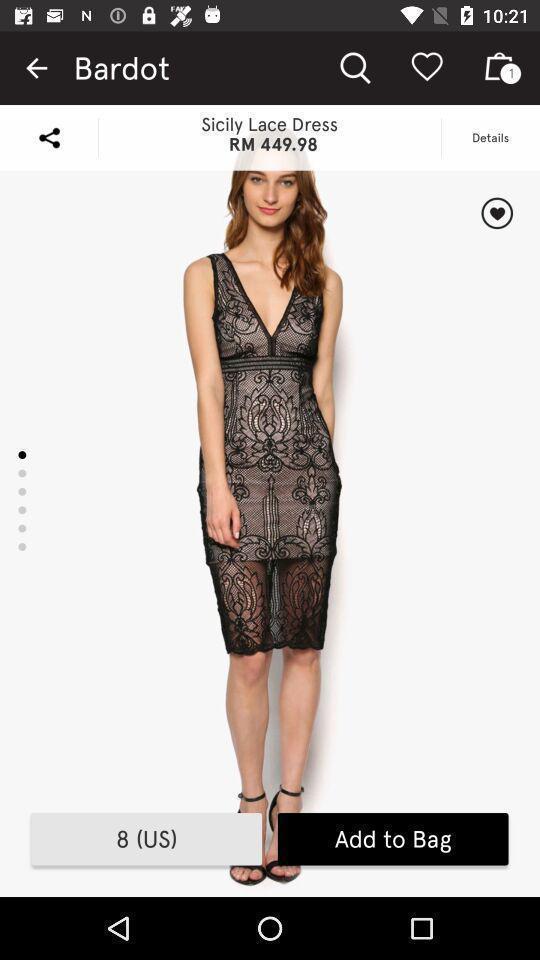Describe the key features of this screenshot. Screen page displaying a product details in shopping application. 